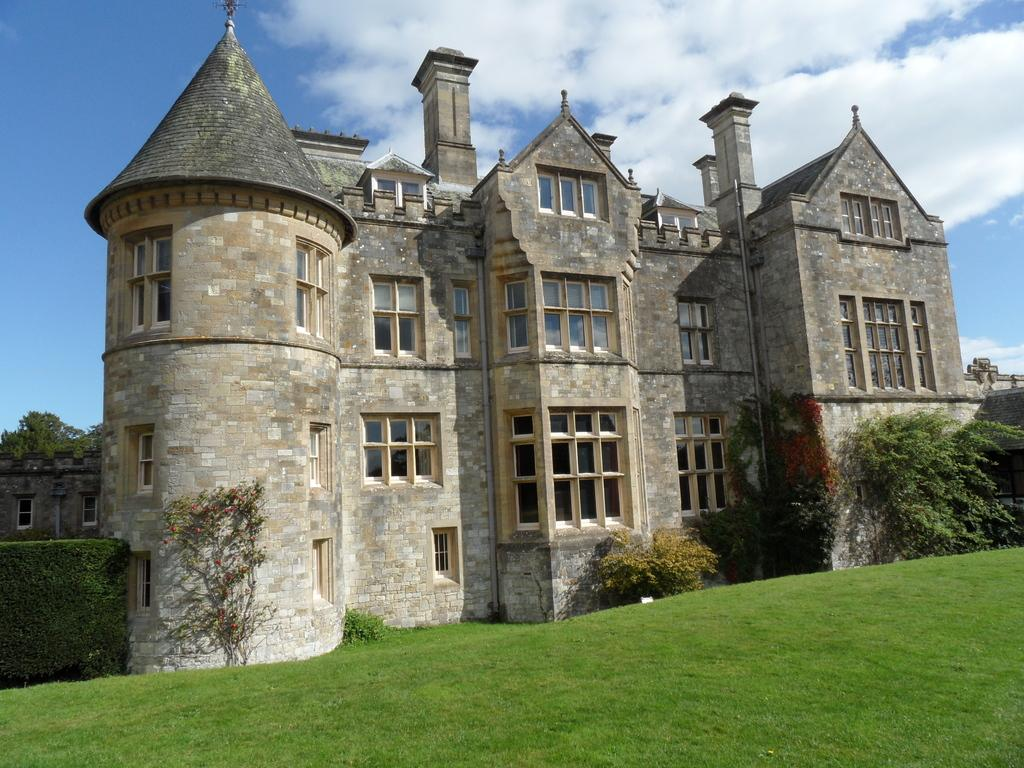What type of structure is present in the image? There is a building in the image. What type of vegetation can be seen in the image? There are shrubs and plants visible in the image. Can the ground be seen in the image? Yes, the ground is visible in the image. What is visible in the background of the image? The sky is visible in the background of the image. What can be seen in the sky in the image? There are clouds in the sky. What type of railway is visible in the image? There is no railway present in the image. What advice would the father give to the mom in the image? There are no people, including a father or mom, present in the image. 